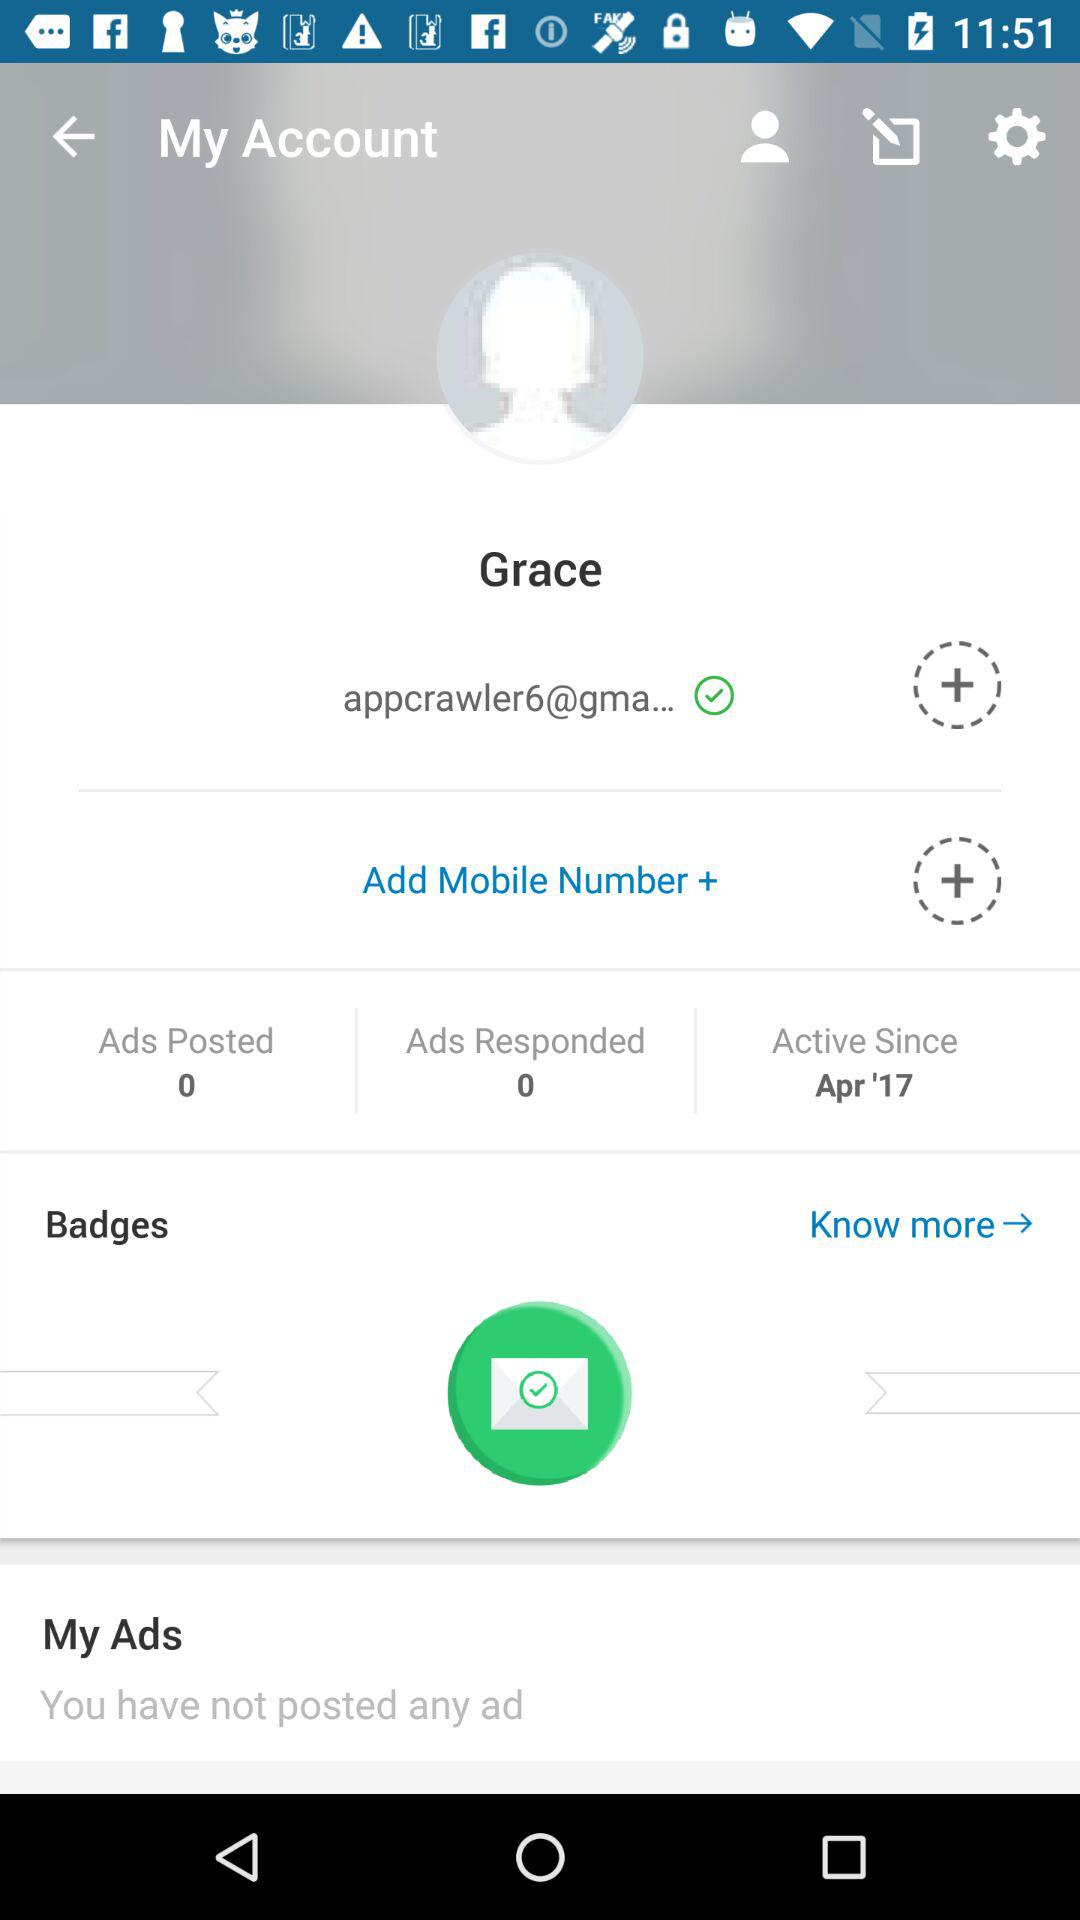What's the total number of ads posted? The total number of ads posted is 0. 